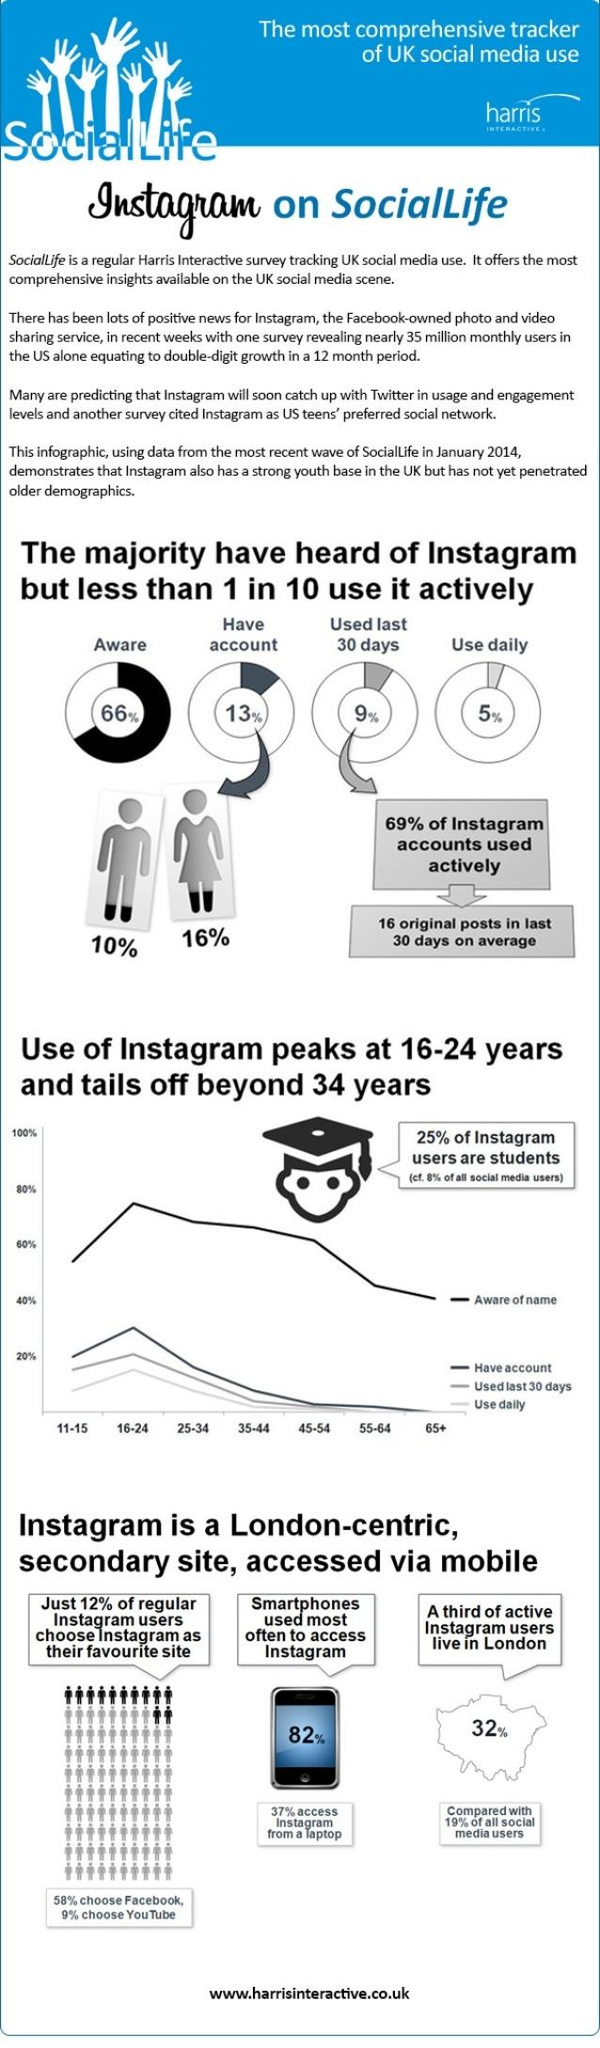Indicate a few pertinent items in this graphic. According to data from January 2014, approximately 32% of Instagram users lived in London. In January 2014, 34% of the UK population was unaware of Instagram. According to a study conducted in January 2014, it was found that only 5% of Instagram accounts in the UK are used daily. According to data collected in January 2014, approximately 10% of account holders on Instagram in the UK are male. As of January 2014, it was found that 82% of people in the UK used smartphones to access Instagram. 